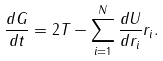Convert formula to latex. <formula><loc_0><loc_0><loc_500><loc_500>\frac { d G } { d t } = 2 T - \sum _ { i = 1 } ^ { N } \frac { d U } { d r _ { i } } r _ { i } .</formula> 